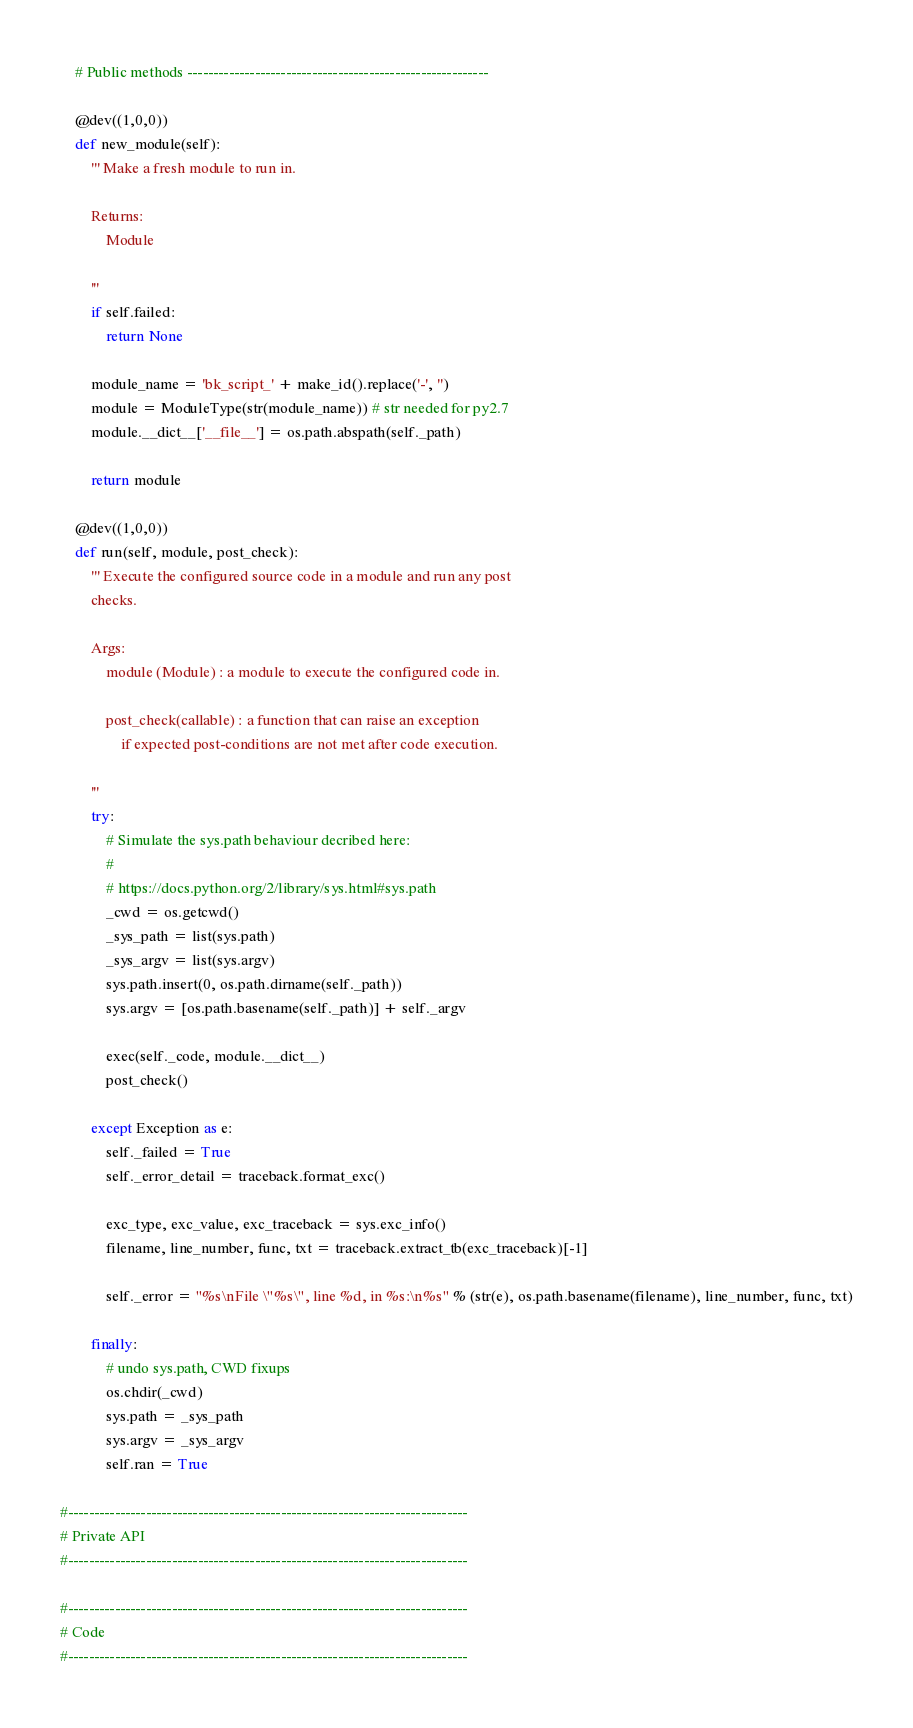Convert code to text. <code><loc_0><loc_0><loc_500><loc_500><_Python_>    # Public methods ----------------------------------------------------------

    @dev((1,0,0))
    def new_module(self):
        ''' Make a fresh module to run in.

        Returns:
            Module

        '''
        if self.failed:
            return None

        module_name = 'bk_script_' + make_id().replace('-', '')
        module = ModuleType(str(module_name)) # str needed for py2.7
        module.__dict__['__file__'] = os.path.abspath(self._path)

        return module

    @dev((1,0,0))
    def run(self, module, post_check):
        ''' Execute the configured source code in a module and run any post
        checks.

        Args:
            module (Module) : a module to execute the configured code in.

            post_check(callable) : a function that can raise an exception
                if expected post-conditions are not met after code execution.

        '''
        try:
            # Simulate the sys.path behaviour decribed here:
            #
            # https://docs.python.org/2/library/sys.html#sys.path
            _cwd = os.getcwd()
            _sys_path = list(sys.path)
            _sys_argv = list(sys.argv)
            sys.path.insert(0, os.path.dirname(self._path))
            sys.argv = [os.path.basename(self._path)] + self._argv

            exec(self._code, module.__dict__)
            post_check()

        except Exception as e:
            self._failed = True
            self._error_detail = traceback.format_exc()

            exc_type, exc_value, exc_traceback = sys.exc_info()
            filename, line_number, func, txt = traceback.extract_tb(exc_traceback)[-1]

            self._error = "%s\nFile \"%s\", line %d, in %s:\n%s" % (str(e), os.path.basename(filename), line_number, func, txt)

        finally:
            # undo sys.path, CWD fixups
            os.chdir(_cwd)
            sys.path = _sys_path
            sys.argv = _sys_argv
            self.ran = True

#-----------------------------------------------------------------------------
# Private API
#-----------------------------------------------------------------------------

#-----------------------------------------------------------------------------
# Code
#-----------------------------------------------------------------------------
</code> 